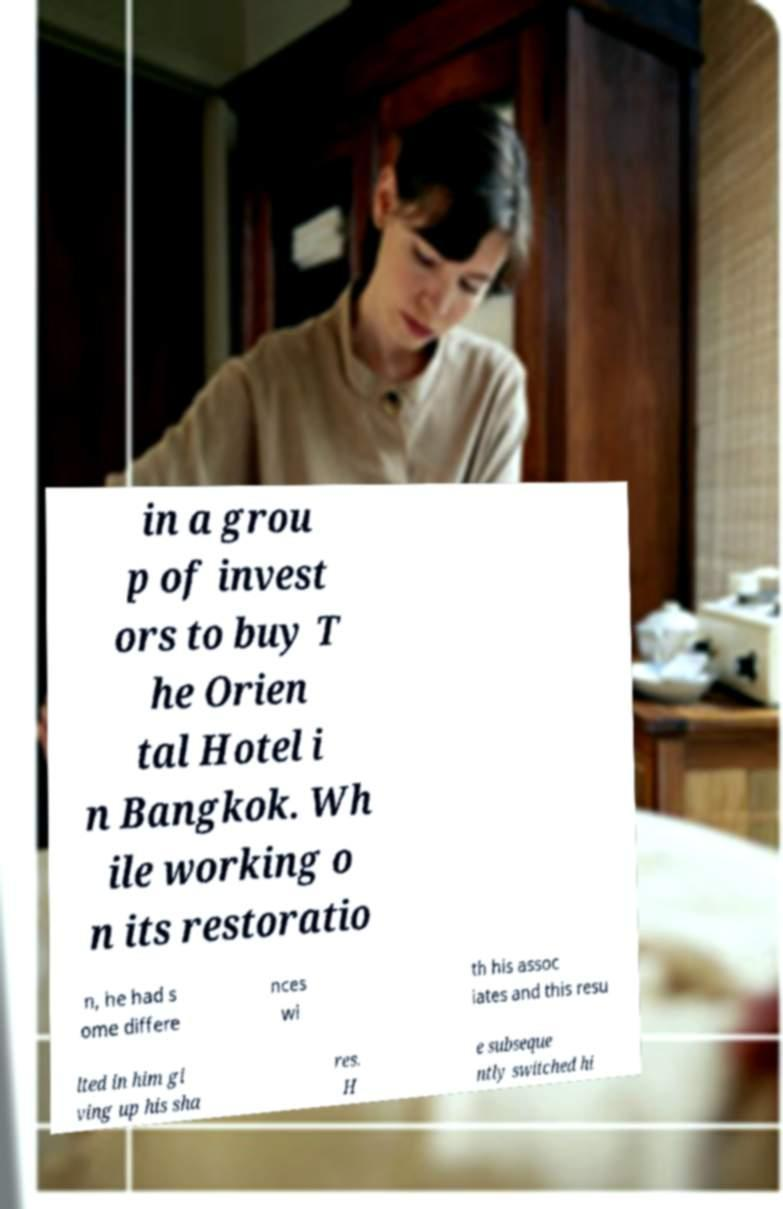Could you extract and type out the text from this image? in a grou p of invest ors to buy T he Orien tal Hotel i n Bangkok. Wh ile working o n its restoratio n, he had s ome differe nces wi th his assoc iates and this resu lted in him gi ving up his sha res. H e subseque ntly switched hi 